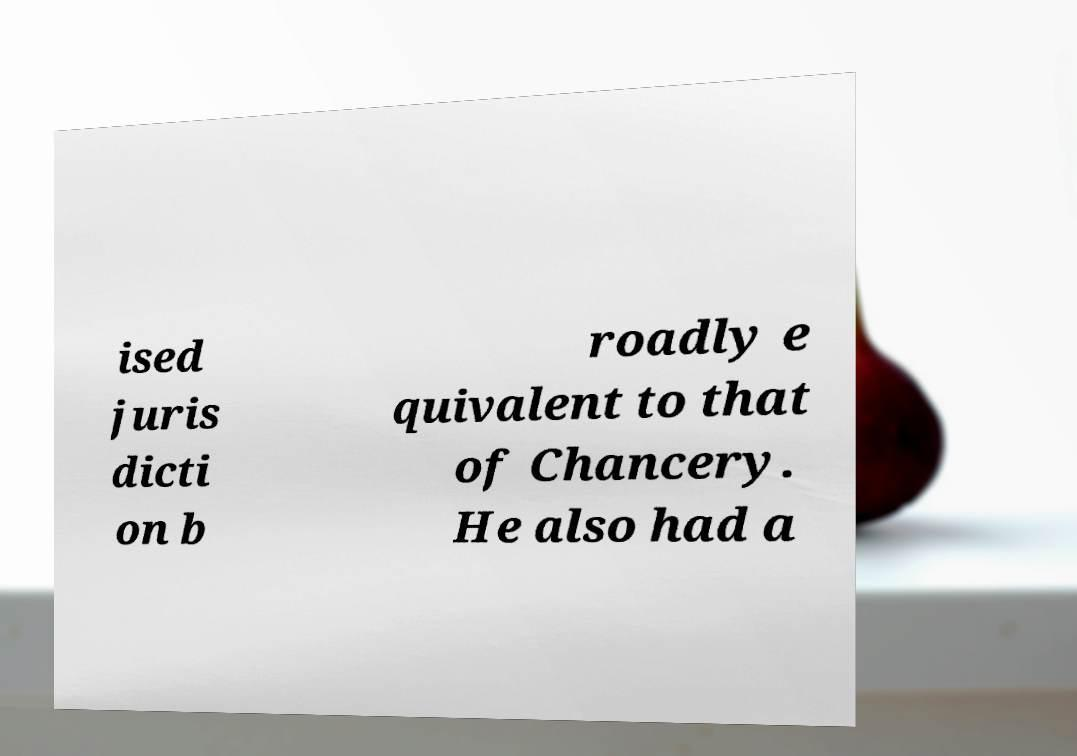Please read and relay the text visible in this image. What does it say? ised juris dicti on b roadly e quivalent to that of Chancery. He also had a 